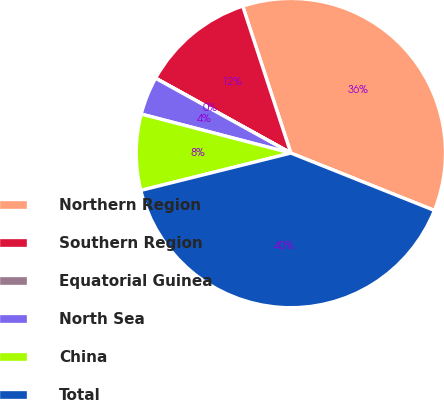Convert chart to OTSL. <chart><loc_0><loc_0><loc_500><loc_500><pie_chart><fcel>Northern Region<fcel>Southern Region<fcel>Equatorial Guinea<fcel>North Sea<fcel>China<fcel>Total<nl><fcel>36.09%<fcel>11.91%<fcel>0.01%<fcel>3.98%<fcel>7.94%<fcel>40.06%<nl></chart> 